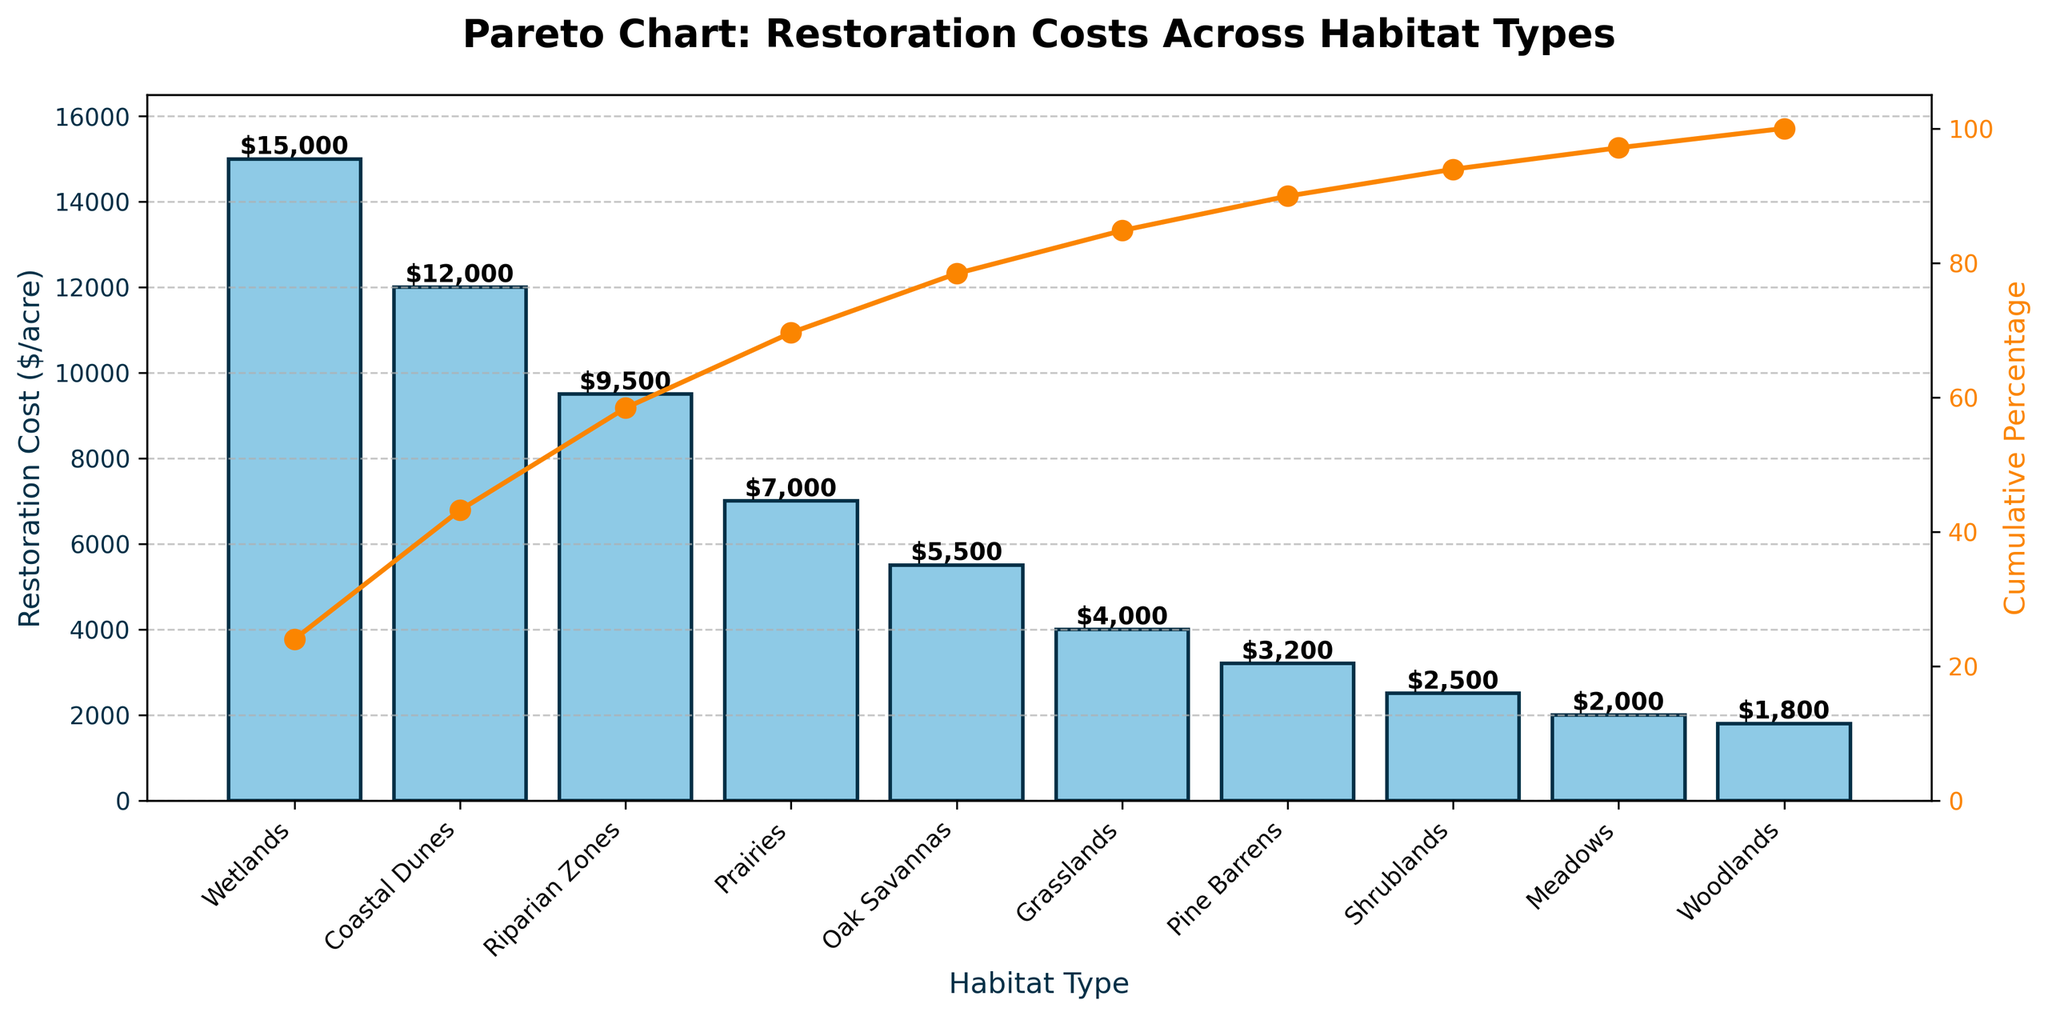Which habitat type has the highest restoration cost? To find the habitat type with the highest restoration cost, look at the bar chart and identify the tallest bar. The tallest bar corresponds to Wetlands.
Answer: Wetlands What is the restoration cost for Woodlands? Locate the bar corresponding to Woodlands and read the height of the bar to find the restoration cost.
Answer: $1,800 How many habitat types have a restoration cost over $10,000 per acre? Identify the bars that exceed the $10,000 mark on the y-axis. Wetlands and Coastal Dunes are the only two habitat types with costs over $10,000.
Answer: 2 Which habitat type has the lowest restoration cost? Look for the shortest bar on the chart. The shortest bar corresponds to Woodlands.
Answer: Woodlands What is the cumulative percentage of restoration costs up to Riparian Zones? To find this, look at the cumulative percentage line and check the value at the Riparian Zones mark.
Answer: 58.91% What is the difference in restoration cost between Oak Savannas and Shrublands? Find the bars for Oak Savannas and Shrublands and take the difference between their heights (costs). 5,500 (Oak Savannas) - 2,500 (Shrublands) = 3,000.
Answer: $3,000 What percentage of the total restoration cost does Prairies cover? First, find the cost of Prairies, then divide it by the total cost and multiply by 100. 7,000 / (sum of all costs) * 100 = 7,000 / 69,500 * 100 ≈ 10.07%.
Answer: 10.07% If you want to restore up to the first 70% of the total restoration costs, until which habitat type should you include? Look at the cumulative percentage line and find where it first exceeds 70%. It is right before Oak Savannas
Answer: Riparian Zones Compare the cumulative percentages of Prairies and Pine Barrens. Which one is higher and by how much? Find the cumulative percentage values for both Prairies and Pine Barrens, then take the difference. Prairies (68.35%) - Pine Barrens (88.06%) = -19.71%.
Answer: Pine Barrens by 19.71% What is the median restoration cost of all habitat types in the chart? List all restoration costs and find the middle value when the list is sorted. The sorted list is {1,800, ..., 15,000}. The median value is the average of the 5th and 6th values (5,500 and 7,000), so (5,500 + 7,000) / 2 = 6,250.
Answer: $6,250 